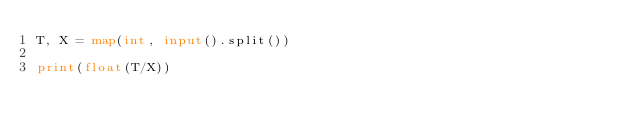<code> <loc_0><loc_0><loc_500><loc_500><_Python_>T, X = map(int, input().split())

print(float(T/X))</code> 